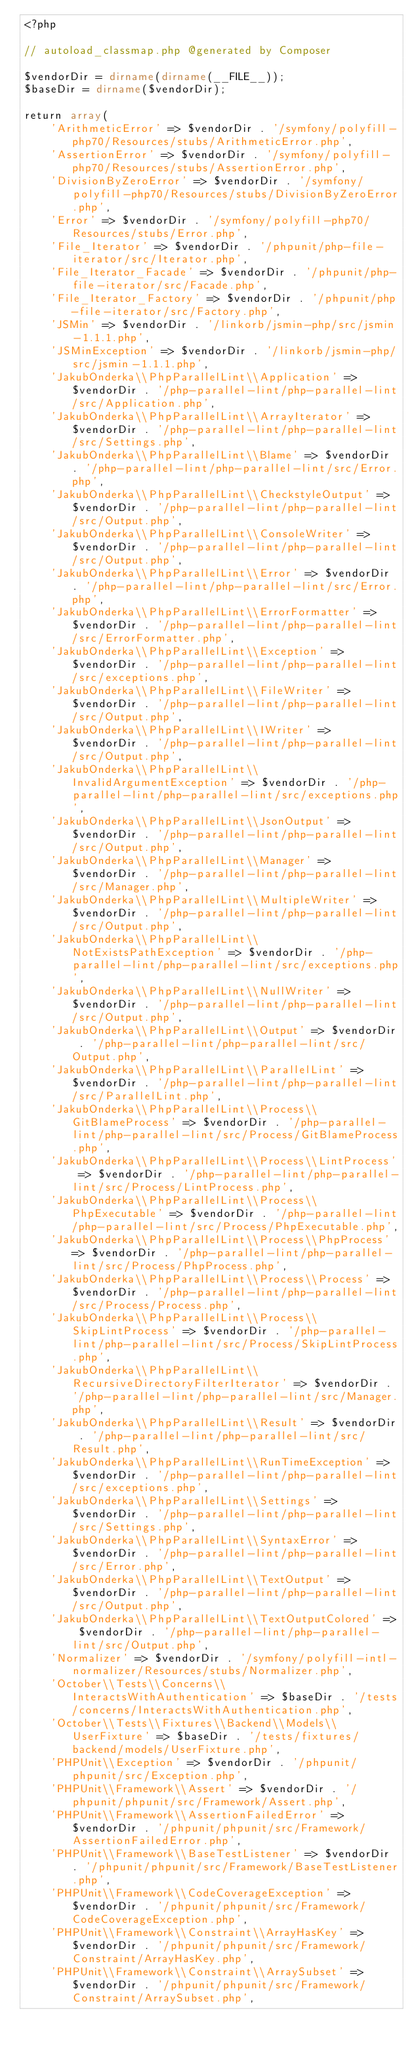<code> <loc_0><loc_0><loc_500><loc_500><_PHP_><?php

// autoload_classmap.php @generated by Composer

$vendorDir = dirname(dirname(__FILE__));
$baseDir = dirname($vendorDir);

return array(
    'ArithmeticError' => $vendorDir . '/symfony/polyfill-php70/Resources/stubs/ArithmeticError.php',
    'AssertionError' => $vendorDir . '/symfony/polyfill-php70/Resources/stubs/AssertionError.php',
    'DivisionByZeroError' => $vendorDir . '/symfony/polyfill-php70/Resources/stubs/DivisionByZeroError.php',
    'Error' => $vendorDir . '/symfony/polyfill-php70/Resources/stubs/Error.php',
    'File_Iterator' => $vendorDir . '/phpunit/php-file-iterator/src/Iterator.php',
    'File_Iterator_Facade' => $vendorDir . '/phpunit/php-file-iterator/src/Facade.php',
    'File_Iterator_Factory' => $vendorDir . '/phpunit/php-file-iterator/src/Factory.php',
    'JSMin' => $vendorDir . '/linkorb/jsmin-php/src/jsmin-1.1.1.php',
    'JSMinException' => $vendorDir . '/linkorb/jsmin-php/src/jsmin-1.1.1.php',
    'JakubOnderka\\PhpParallelLint\\Application' => $vendorDir . '/php-parallel-lint/php-parallel-lint/src/Application.php',
    'JakubOnderka\\PhpParallelLint\\ArrayIterator' => $vendorDir . '/php-parallel-lint/php-parallel-lint/src/Settings.php',
    'JakubOnderka\\PhpParallelLint\\Blame' => $vendorDir . '/php-parallel-lint/php-parallel-lint/src/Error.php',
    'JakubOnderka\\PhpParallelLint\\CheckstyleOutput' => $vendorDir . '/php-parallel-lint/php-parallel-lint/src/Output.php',
    'JakubOnderka\\PhpParallelLint\\ConsoleWriter' => $vendorDir . '/php-parallel-lint/php-parallel-lint/src/Output.php',
    'JakubOnderka\\PhpParallelLint\\Error' => $vendorDir . '/php-parallel-lint/php-parallel-lint/src/Error.php',
    'JakubOnderka\\PhpParallelLint\\ErrorFormatter' => $vendorDir . '/php-parallel-lint/php-parallel-lint/src/ErrorFormatter.php',
    'JakubOnderka\\PhpParallelLint\\Exception' => $vendorDir . '/php-parallel-lint/php-parallel-lint/src/exceptions.php',
    'JakubOnderka\\PhpParallelLint\\FileWriter' => $vendorDir . '/php-parallel-lint/php-parallel-lint/src/Output.php',
    'JakubOnderka\\PhpParallelLint\\IWriter' => $vendorDir . '/php-parallel-lint/php-parallel-lint/src/Output.php',
    'JakubOnderka\\PhpParallelLint\\InvalidArgumentException' => $vendorDir . '/php-parallel-lint/php-parallel-lint/src/exceptions.php',
    'JakubOnderka\\PhpParallelLint\\JsonOutput' => $vendorDir . '/php-parallel-lint/php-parallel-lint/src/Output.php',
    'JakubOnderka\\PhpParallelLint\\Manager' => $vendorDir . '/php-parallel-lint/php-parallel-lint/src/Manager.php',
    'JakubOnderka\\PhpParallelLint\\MultipleWriter' => $vendorDir . '/php-parallel-lint/php-parallel-lint/src/Output.php',
    'JakubOnderka\\PhpParallelLint\\NotExistsPathException' => $vendorDir . '/php-parallel-lint/php-parallel-lint/src/exceptions.php',
    'JakubOnderka\\PhpParallelLint\\NullWriter' => $vendorDir . '/php-parallel-lint/php-parallel-lint/src/Output.php',
    'JakubOnderka\\PhpParallelLint\\Output' => $vendorDir . '/php-parallel-lint/php-parallel-lint/src/Output.php',
    'JakubOnderka\\PhpParallelLint\\ParallelLint' => $vendorDir . '/php-parallel-lint/php-parallel-lint/src/ParallelLint.php',
    'JakubOnderka\\PhpParallelLint\\Process\\GitBlameProcess' => $vendorDir . '/php-parallel-lint/php-parallel-lint/src/Process/GitBlameProcess.php',
    'JakubOnderka\\PhpParallelLint\\Process\\LintProcess' => $vendorDir . '/php-parallel-lint/php-parallel-lint/src/Process/LintProcess.php',
    'JakubOnderka\\PhpParallelLint\\Process\\PhpExecutable' => $vendorDir . '/php-parallel-lint/php-parallel-lint/src/Process/PhpExecutable.php',
    'JakubOnderka\\PhpParallelLint\\Process\\PhpProcess' => $vendorDir . '/php-parallel-lint/php-parallel-lint/src/Process/PhpProcess.php',
    'JakubOnderka\\PhpParallelLint\\Process\\Process' => $vendorDir . '/php-parallel-lint/php-parallel-lint/src/Process/Process.php',
    'JakubOnderka\\PhpParallelLint\\Process\\SkipLintProcess' => $vendorDir . '/php-parallel-lint/php-parallel-lint/src/Process/SkipLintProcess.php',
    'JakubOnderka\\PhpParallelLint\\RecursiveDirectoryFilterIterator' => $vendorDir . '/php-parallel-lint/php-parallel-lint/src/Manager.php',
    'JakubOnderka\\PhpParallelLint\\Result' => $vendorDir . '/php-parallel-lint/php-parallel-lint/src/Result.php',
    'JakubOnderka\\PhpParallelLint\\RunTimeException' => $vendorDir . '/php-parallel-lint/php-parallel-lint/src/exceptions.php',
    'JakubOnderka\\PhpParallelLint\\Settings' => $vendorDir . '/php-parallel-lint/php-parallel-lint/src/Settings.php',
    'JakubOnderka\\PhpParallelLint\\SyntaxError' => $vendorDir . '/php-parallel-lint/php-parallel-lint/src/Error.php',
    'JakubOnderka\\PhpParallelLint\\TextOutput' => $vendorDir . '/php-parallel-lint/php-parallel-lint/src/Output.php',
    'JakubOnderka\\PhpParallelLint\\TextOutputColored' => $vendorDir . '/php-parallel-lint/php-parallel-lint/src/Output.php',
    'Normalizer' => $vendorDir . '/symfony/polyfill-intl-normalizer/Resources/stubs/Normalizer.php',
    'October\\Tests\\Concerns\\InteractsWithAuthentication' => $baseDir . '/tests/concerns/InteractsWithAuthentication.php',
    'October\\Tests\\Fixtures\\Backend\\Models\\UserFixture' => $baseDir . '/tests/fixtures/backend/models/UserFixture.php',
    'PHPUnit\\Exception' => $vendorDir . '/phpunit/phpunit/src/Exception.php',
    'PHPUnit\\Framework\\Assert' => $vendorDir . '/phpunit/phpunit/src/Framework/Assert.php',
    'PHPUnit\\Framework\\AssertionFailedError' => $vendorDir . '/phpunit/phpunit/src/Framework/AssertionFailedError.php',
    'PHPUnit\\Framework\\BaseTestListener' => $vendorDir . '/phpunit/phpunit/src/Framework/BaseTestListener.php',
    'PHPUnit\\Framework\\CodeCoverageException' => $vendorDir . '/phpunit/phpunit/src/Framework/CodeCoverageException.php',
    'PHPUnit\\Framework\\Constraint\\ArrayHasKey' => $vendorDir . '/phpunit/phpunit/src/Framework/Constraint/ArrayHasKey.php',
    'PHPUnit\\Framework\\Constraint\\ArraySubset' => $vendorDir . '/phpunit/phpunit/src/Framework/Constraint/ArraySubset.php',</code> 